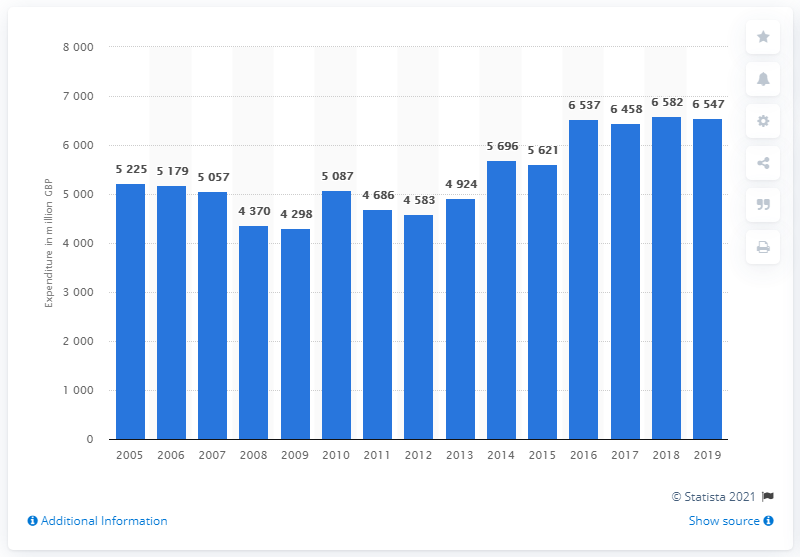Mention a couple of crucial points in this snapshot. In the year 2019, the annual spending on pets and related products in the United Kingdom reached a total of 6547. 